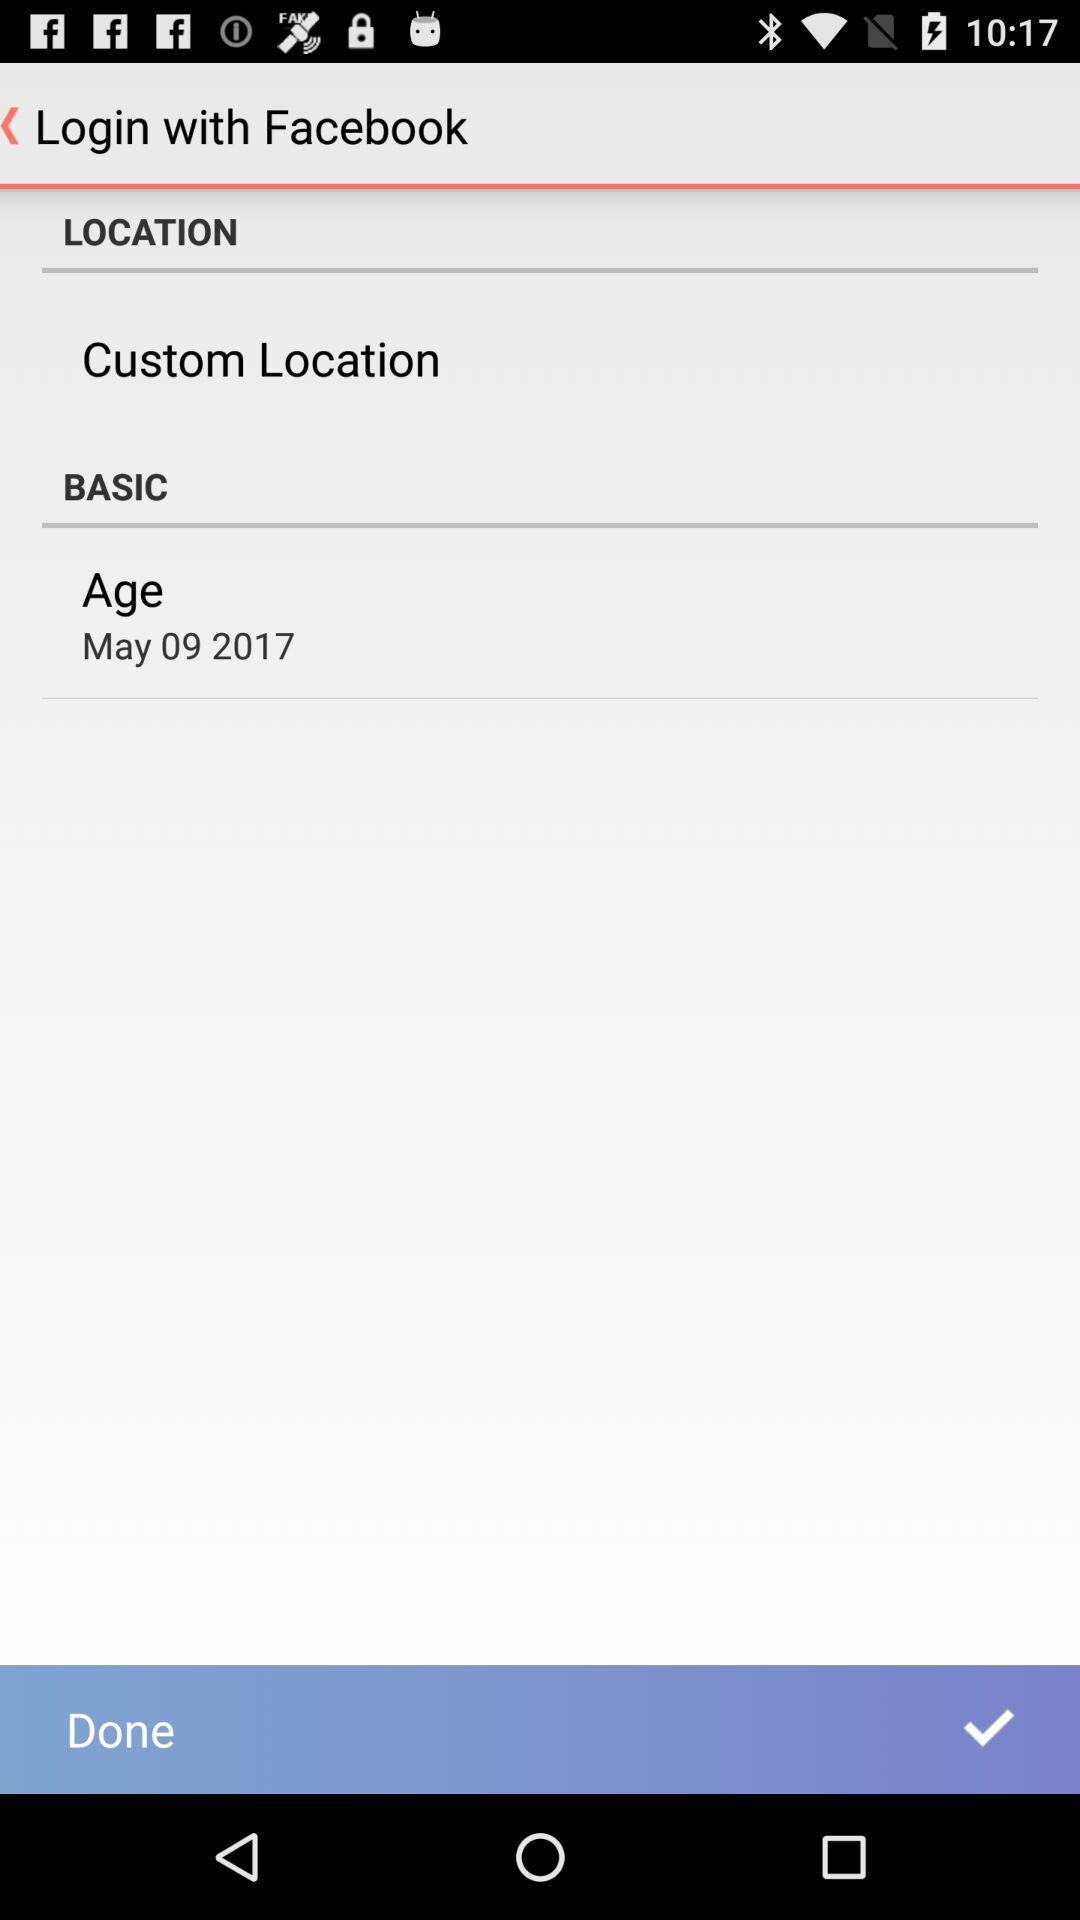What is the age? The age is May 9, 2017. 